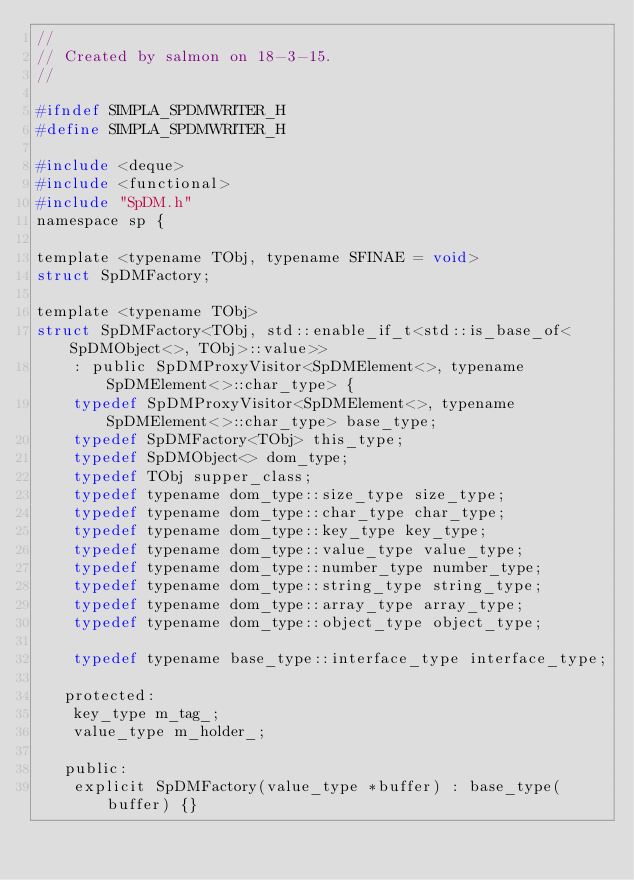Convert code to text. <code><loc_0><loc_0><loc_500><loc_500><_C_>//
// Created by salmon on 18-3-15.
//

#ifndef SIMPLA_SPDMWRITER_H
#define SIMPLA_SPDMWRITER_H

#include <deque>
#include <functional>
#include "SpDM.h"
namespace sp {

template <typename TObj, typename SFINAE = void>
struct SpDMFactory;

template <typename TObj>
struct SpDMFactory<TObj, std::enable_if_t<std::is_base_of<SpDMObject<>, TObj>::value>>
    : public SpDMProxyVisitor<SpDMElement<>, typename SpDMElement<>::char_type> {
    typedef SpDMProxyVisitor<SpDMElement<>, typename SpDMElement<>::char_type> base_type;
    typedef SpDMFactory<TObj> this_type;
    typedef SpDMObject<> dom_type;
    typedef TObj supper_class;
    typedef typename dom_type::size_type size_type;
    typedef typename dom_type::char_type char_type;
    typedef typename dom_type::key_type key_type;
    typedef typename dom_type::value_type value_type;
    typedef typename dom_type::number_type number_type;
    typedef typename dom_type::string_type string_type;
    typedef typename dom_type::array_type array_type;
    typedef typename dom_type::object_type object_type;

    typedef typename base_type::interface_type interface_type;

   protected:
    key_type m_tag_;
    value_type m_holder_;

   public:
    explicit SpDMFactory(value_type *buffer) : base_type(buffer) {}</code> 